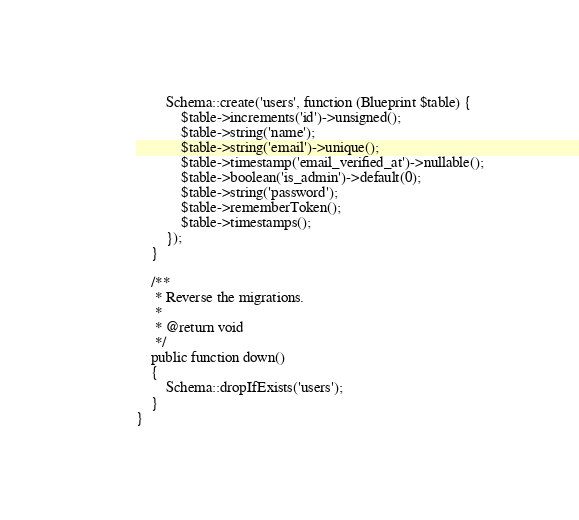<code> <loc_0><loc_0><loc_500><loc_500><_PHP_>        Schema::create('users', function (Blueprint $table) {
            $table->increments('id')->unsigned();
            $table->string('name');
            $table->string('email')->unique();
            $table->timestamp('email_verified_at')->nullable();
            $table->boolean('is_admin')->default(0);
            $table->string('password');
            $table->rememberToken();
            $table->timestamps();
        });
    }

    /**
     * Reverse the migrations.
     *
     * @return void
     */
    public function down()
    {
        Schema::dropIfExists('users');
    }
}
</code> 